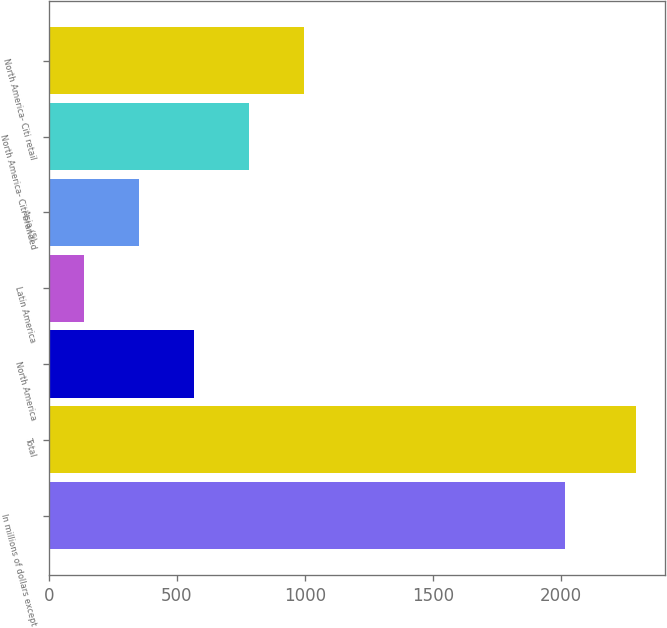Convert chart. <chart><loc_0><loc_0><loc_500><loc_500><bar_chart><fcel>In millions of dollars except<fcel>Total<fcel>North America<fcel>Latin America<fcel>Asia (5)<fcel>North America- Citi-branded<fcel>North America- Citi retail<nl><fcel>2016<fcel>2293<fcel>567.4<fcel>136<fcel>351.7<fcel>783.1<fcel>998.8<nl></chart> 